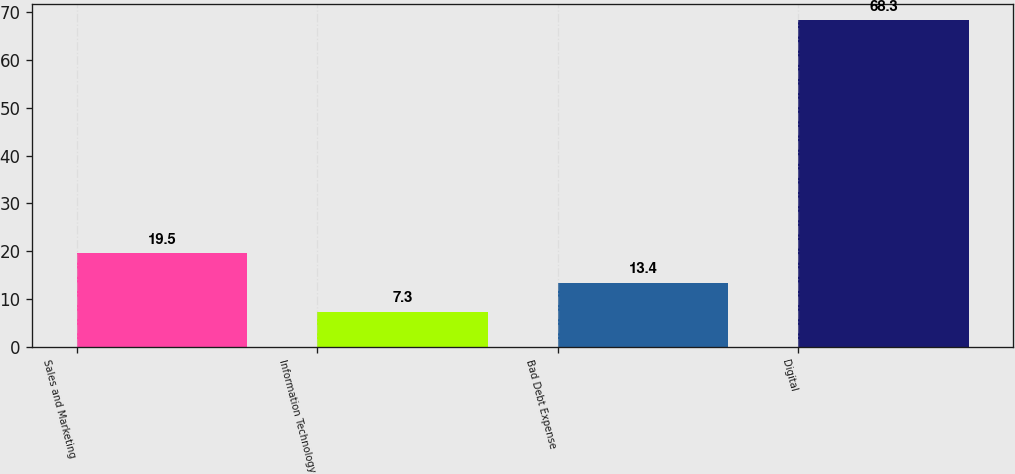Convert chart to OTSL. <chart><loc_0><loc_0><loc_500><loc_500><bar_chart><fcel>Sales and Marketing<fcel>Information Technology<fcel>Bad Debt Expense<fcel>Digital<nl><fcel>19.5<fcel>7.3<fcel>13.4<fcel>68.3<nl></chart> 